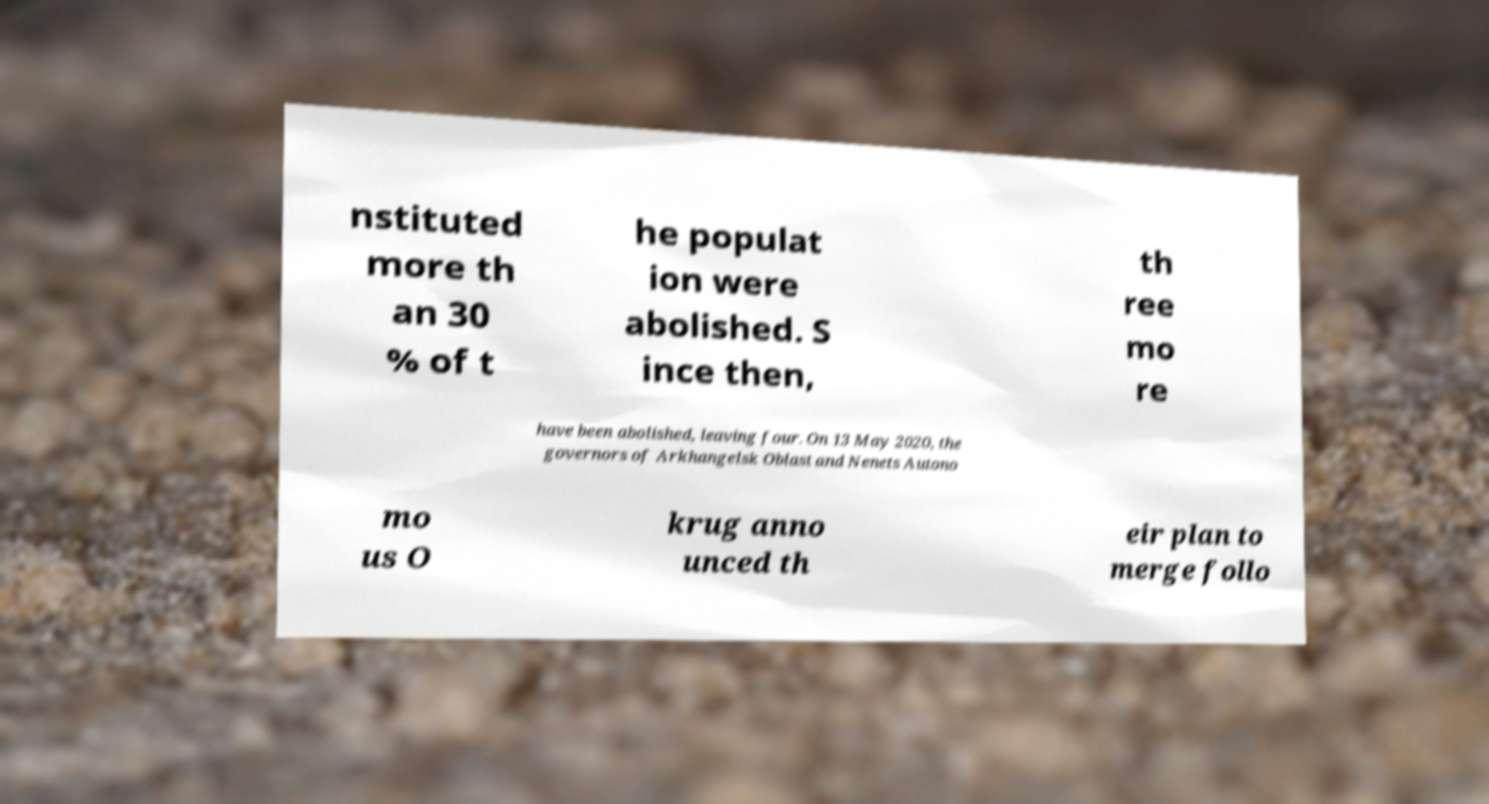Please identify and transcribe the text found in this image. nstituted more th an 30 % of t he populat ion were abolished. S ince then, th ree mo re have been abolished, leaving four. On 13 May 2020, the governors of Arkhangelsk Oblast and Nenets Autono mo us O krug anno unced th eir plan to merge follo 